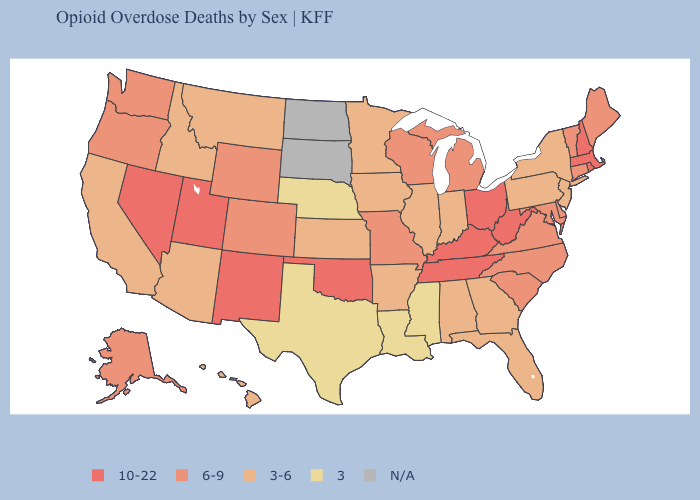Among the states that border Minnesota , does Iowa have the highest value?
Be succinct. No. What is the value of Alaska?
Keep it brief. 6-9. Does the first symbol in the legend represent the smallest category?
Concise answer only. No. What is the highest value in the USA?
Be succinct. 10-22. Among the states that border Minnesota , does Wisconsin have the highest value?
Concise answer only. Yes. Name the states that have a value in the range 3-6?
Quick response, please. Alabama, Arizona, Arkansas, California, Florida, Georgia, Hawaii, Idaho, Illinois, Indiana, Iowa, Kansas, Minnesota, Montana, New Jersey, New York, Pennsylvania. Does Nebraska have the lowest value in the USA?
Keep it brief. Yes. Does the first symbol in the legend represent the smallest category?
Give a very brief answer. No. Which states have the lowest value in the Northeast?
Short answer required. New Jersey, New York, Pennsylvania. Does the map have missing data?
Concise answer only. Yes. Does the map have missing data?
Keep it brief. Yes. What is the lowest value in the Northeast?
Keep it brief. 3-6. What is the highest value in states that border Montana?
Concise answer only. 6-9. Does Mississippi have the lowest value in the USA?
Quick response, please. Yes. 